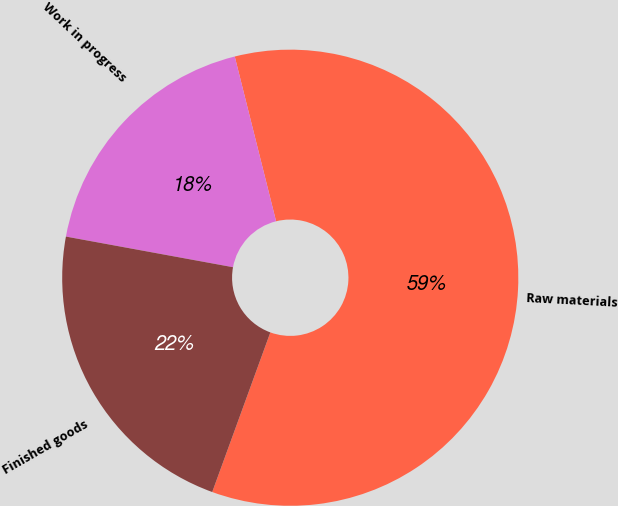Convert chart. <chart><loc_0><loc_0><loc_500><loc_500><pie_chart><fcel>Raw materials<fcel>Work in progress<fcel>Finished goods<nl><fcel>59.47%<fcel>18.2%<fcel>22.33%<nl></chart> 